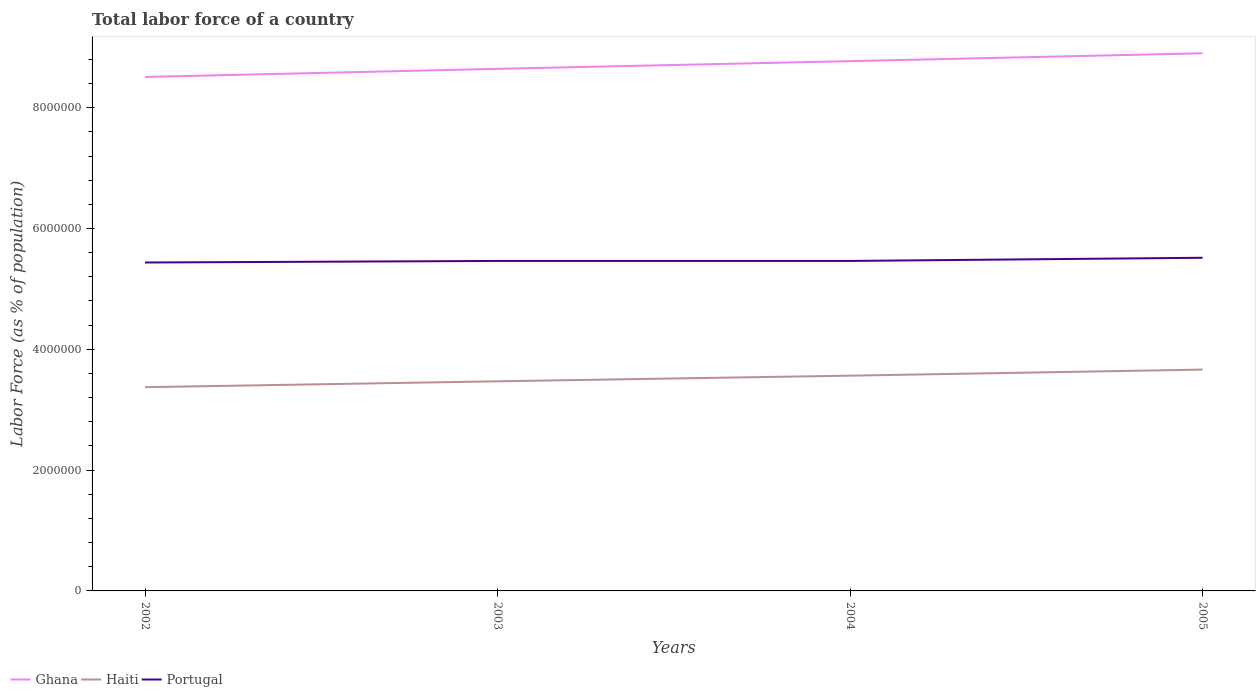Is the number of lines equal to the number of legend labels?
Give a very brief answer. Yes. Across all years, what is the maximum percentage of labor force in Haiti?
Provide a short and direct response. 3.37e+06. In which year was the percentage of labor force in Ghana maximum?
Ensure brevity in your answer.  2002. What is the total percentage of labor force in Ghana in the graph?
Your response must be concise. -2.57e+05. What is the difference between the highest and the second highest percentage of labor force in Haiti?
Offer a very short reply. 2.91e+05. How many years are there in the graph?
Provide a short and direct response. 4. What is the difference between two consecutive major ticks on the Y-axis?
Your answer should be compact. 2.00e+06. Where does the legend appear in the graph?
Give a very brief answer. Bottom left. How are the legend labels stacked?
Offer a very short reply. Horizontal. What is the title of the graph?
Ensure brevity in your answer.  Total labor force of a country. Does "Low income" appear as one of the legend labels in the graph?
Your response must be concise. No. What is the label or title of the X-axis?
Keep it short and to the point. Years. What is the label or title of the Y-axis?
Offer a very short reply. Labor Force (as % of population). What is the Labor Force (as % of population) in Ghana in 2002?
Your answer should be compact. 8.51e+06. What is the Labor Force (as % of population) in Haiti in 2002?
Your response must be concise. 3.37e+06. What is the Labor Force (as % of population) in Portugal in 2002?
Keep it short and to the point. 5.44e+06. What is the Labor Force (as % of population) of Ghana in 2003?
Your answer should be compact. 8.64e+06. What is the Labor Force (as % of population) in Haiti in 2003?
Keep it short and to the point. 3.47e+06. What is the Labor Force (as % of population) of Portugal in 2003?
Keep it short and to the point. 5.46e+06. What is the Labor Force (as % of population) of Ghana in 2004?
Make the answer very short. 8.77e+06. What is the Labor Force (as % of population) of Haiti in 2004?
Your answer should be compact. 3.56e+06. What is the Labor Force (as % of population) in Portugal in 2004?
Your answer should be compact. 5.46e+06. What is the Labor Force (as % of population) of Ghana in 2005?
Offer a terse response. 8.90e+06. What is the Labor Force (as % of population) in Haiti in 2005?
Offer a very short reply. 3.66e+06. What is the Labor Force (as % of population) of Portugal in 2005?
Offer a terse response. 5.52e+06. Across all years, what is the maximum Labor Force (as % of population) in Ghana?
Make the answer very short. 8.90e+06. Across all years, what is the maximum Labor Force (as % of population) of Haiti?
Give a very brief answer. 3.66e+06. Across all years, what is the maximum Labor Force (as % of population) in Portugal?
Keep it short and to the point. 5.52e+06. Across all years, what is the minimum Labor Force (as % of population) of Ghana?
Your answer should be compact. 8.51e+06. Across all years, what is the minimum Labor Force (as % of population) of Haiti?
Provide a succinct answer. 3.37e+06. Across all years, what is the minimum Labor Force (as % of population) of Portugal?
Offer a terse response. 5.44e+06. What is the total Labor Force (as % of population) in Ghana in the graph?
Your answer should be compact. 3.48e+07. What is the total Labor Force (as % of population) in Haiti in the graph?
Your answer should be compact. 1.41e+07. What is the total Labor Force (as % of population) of Portugal in the graph?
Offer a terse response. 2.19e+07. What is the difference between the Labor Force (as % of population) of Ghana in 2002 and that in 2003?
Keep it short and to the point. -1.35e+05. What is the difference between the Labor Force (as % of population) in Haiti in 2002 and that in 2003?
Provide a succinct answer. -9.76e+04. What is the difference between the Labor Force (as % of population) of Portugal in 2002 and that in 2003?
Keep it short and to the point. -2.58e+04. What is the difference between the Labor Force (as % of population) in Ghana in 2002 and that in 2004?
Offer a terse response. -2.62e+05. What is the difference between the Labor Force (as % of population) in Haiti in 2002 and that in 2004?
Make the answer very short. -1.91e+05. What is the difference between the Labor Force (as % of population) in Portugal in 2002 and that in 2004?
Give a very brief answer. -2.60e+04. What is the difference between the Labor Force (as % of population) of Ghana in 2002 and that in 2005?
Provide a short and direct response. -3.92e+05. What is the difference between the Labor Force (as % of population) of Haiti in 2002 and that in 2005?
Provide a short and direct response. -2.91e+05. What is the difference between the Labor Force (as % of population) of Portugal in 2002 and that in 2005?
Ensure brevity in your answer.  -7.84e+04. What is the difference between the Labor Force (as % of population) of Ghana in 2003 and that in 2004?
Offer a terse response. -1.27e+05. What is the difference between the Labor Force (as % of population) in Haiti in 2003 and that in 2004?
Make the answer very short. -9.34e+04. What is the difference between the Labor Force (as % of population) in Portugal in 2003 and that in 2004?
Give a very brief answer. -173. What is the difference between the Labor Force (as % of population) of Ghana in 2003 and that in 2005?
Offer a terse response. -2.57e+05. What is the difference between the Labor Force (as % of population) of Haiti in 2003 and that in 2005?
Offer a very short reply. -1.94e+05. What is the difference between the Labor Force (as % of population) of Portugal in 2003 and that in 2005?
Give a very brief answer. -5.25e+04. What is the difference between the Labor Force (as % of population) of Ghana in 2004 and that in 2005?
Offer a terse response. -1.31e+05. What is the difference between the Labor Force (as % of population) of Haiti in 2004 and that in 2005?
Offer a terse response. -1.00e+05. What is the difference between the Labor Force (as % of population) of Portugal in 2004 and that in 2005?
Offer a very short reply. -5.23e+04. What is the difference between the Labor Force (as % of population) in Ghana in 2002 and the Labor Force (as % of population) in Haiti in 2003?
Make the answer very short. 5.04e+06. What is the difference between the Labor Force (as % of population) in Ghana in 2002 and the Labor Force (as % of population) in Portugal in 2003?
Keep it short and to the point. 3.05e+06. What is the difference between the Labor Force (as % of population) in Haiti in 2002 and the Labor Force (as % of population) in Portugal in 2003?
Offer a very short reply. -2.09e+06. What is the difference between the Labor Force (as % of population) of Ghana in 2002 and the Labor Force (as % of population) of Haiti in 2004?
Provide a short and direct response. 4.95e+06. What is the difference between the Labor Force (as % of population) in Ghana in 2002 and the Labor Force (as % of population) in Portugal in 2004?
Offer a very short reply. 3.05e+06. What is the difference between the Labor Force (as % of population) of Haiti in 2002 and the Labor Force (as % of population) of Portugal in 2004?
Ensure brevity in your answer.  -2.09e+06. What is the difference between the Labor Force (as % of population) in Ghana in 2002 and the Labor Force (as % of population) in Haiti in 2005?
Make the answer very short. 4.84e+06. What is the difference between the Labor Force (as % of population) of Ghana in 2002 and the Labor Force (as % of population) of Portugal in 2005?
Give a very brief answer. 2.99e+06. What is the difference between the Labor Force (as % of population) of Haiti in 2002 and the Labor Force (as % of population) of Portugal in 2005?
Provide a succinct answer. -2.14e+06. What is the difference between the Labor Force (as % of population) of Ghana in 2003 and the Labor Force (as % of population) of Haiti in 2004?
Offer a terse response. 5.08e+06. What is the difference between the Labor Force (as % of population) in Ghana in 2003 and the Labor Force (as % of population) in Portugal in 2004?
Keep it short and to the point. 3.18e+06. What is the difference between the Labor Force (as % of population) of Haiti in 2003 and the Labor Force (as % of population) of Portugal in 2004?
Offer a terse response. -1.99e+06. What is the difference between the Labor Force (as % of population) in Ghana in 2003 and the Labor Force (as % of population) in Haiti in 2005?
Your answer should be compact. 4.98e+06. What is the difference between the Labor Force (as % of population) of Ghana in 2003 and the Labor Force (as % of population) of Portugal in 2005?
Offer a very short reply. 3.13e+06. What is the difference between the Labor Force (as % of population) of Haiti in 2003 and the Labor Force (as % of population) of Portugal in 2005?
Provide a succinct answer. -2.04e+06. What is the difference between the Labor Force (as % of population) of Ghana in 2004 and the Labor Force (as % of population) of Haiti in 2005?
Offer a very short reply. 5.11e+06. What is the difference between the Labor Force (as % of population) in Ghana in 2004 and the Labor Force (as % of population) in Portugal in 2005?
Your response must be concise. 3.26e+06. What is the difference between the Labor Force (as % of population) of Haiti in 2004 and the Labor Force (as % of population) of Portugal in 2005?
Make the answer very short. -1.95e+06. What is the average Labor Force (as % of population) of Ghana per year?
Your answer should be very brief. 8.71e+06. What is the average Labor Force (as % of population) of Haiti per year?
Ensure brevity in your answer.  3.52e+06. What is the average Labor Force (as % of population) of Portugal per year?
Give a very brief answer. 5.47e+06. In the year 2002, what is the difference between the Labor Force (as % of population) in Ghana and Labor Force (as % of population) in Haiti?
Your answer should be very brief. 5.14e+06. In the year 2002, what is the difference between the Labor Force (as % of population) of Ghana and Labor Force (as % of population) of Portugal?
Your answer should be very brief. 3.07e+06. In the year 2002, what is the difference between the Labor Force (as % of population) in Haiti and Labor Force (as % of population) in Portugal?
Provide a succinct answer. -2.06e+06. In the year 2003, what is the difference between the Labor Force (as % of population) of Ghana and Labor Force (as % of population) of Haiti?
Your response must be concise. 5.17e+06. In the year 2003, what is the difference between the Labor Force (as % of population) of Ghana and Labor Force (as % of population) of Portugal?
Offer a very short reply. 3.18e+06. In the year 2003, what is the difference between the Labor Force (as % of population) in Haiti and Labor Force (as % of population) in Portugal?
Offer a very short reply. -1.99e+06. In the year 2004, what is the difference between the Labor Force (as % of population) of Ghana and Labor Force (as % of population) of Haiti?
Offer a terse response. 5.21e+06. In the year 2004, what is the difference between the Labor Force (as % of population) of Ghana and Labor Force (as % of population) of Portugal?
Your response must be concise. 3.31e+06. In the year 2004, what is the difference between the Labor Force (as % of population) of Haiti and Labor Force (as % of population) of Portugal?
Offer a terse response. -1.90e+06. In the year 2005, what is the difference between the Labor Force (as % of population) in Ghana and Labor Force (as % of population) in Haiti?
Provide a short and direct response. 5.24e+06. In the year 2005, what is the difference between the Labor Force (as % of population) of Ghana and Labor Force (as % of population) of Portugal?
Offer a very short reply. 3.39e+06. In the year 2005, what is the difference between the Labor Force (as % of population) of Haiti and Labor Force (as % of population) of Portugal?
Your answer should be compact. -1.85e+06. What is the ratio of the Labor Force (as % of population) in Ghana in 2002 to that in 2003?
Ensure brevity in your answer.  0.98. What is the ratio of the Labor Force (as % of population) in Haiti in 2002 to that in 2003?
Provide a succinct answer. 0.97. What is the ratio of the Labor Force (as % of population) in Ghana in 2002 to that in 2004?
Provide a succinct answer. 0.97. What is the ratio of the Labor Force (as % of population) in Haiti in 2002 to that in 2004?
Your response must be concise. 0.95. What is the ratio of the Labor Force (as % of population) of Ghana in 2002 to that in 2005?
Provide a short and direct response. 0.96. What is the ratio of the Labor Force (as % of population) in Haiti in 2002 to that in 2005?
Your answer should be very brief. 0.92. What is the ratio of the Labor Force (as % of population) of Portugal in 2002 to that in 2005?
Provide a short and direct response. 0.99. What is the ratio of the Labor Force (as % of population) in Ghana in 2003 to that in 2004?
Keep it short and to the point. 0.99. What is the ratio of the Labor Force (as % of population) of Haiti in 2003 to that in 2004?
Make the answer very short. 0.97. What is the ratio of the Labor Force (as % of population) of Portugal in 2003 to that in 2004?
Provide a short and direct response. 1. What is the ratio of the Labor Force (as % of population) in Ghana in 2003 to that in 2005?
Provide a short and direct response. 0.97. What is the ratio of the Labor Force (as % of population) of Haiti in 2003 to that in 2005?
Offer a terse response. 0.95. What is the ratio of the Labor Force (as % of population) in Portugal in 2003 to that in 2005?
Provide a short and direct response. 0.99. What is the ratio of the Labor Force (as % of population) in Ghana in 2004 to that in 2005?
Give a very brief answer. 0.99. What is the ratio of the Labor Force (as % of population) of Haiti in 2004 to that in 2005?
Provide a short and direct response. 0.97. What is the difference between the highest and the second highest Labor Force (as % of population) in Ghana?
Your answer should be compact. 1.31e+05. What is the difference between the highest and the second highest Labor Force (as % of population) in Haiti?
Make the answer very short. 1.00e+05. What is the difference between the highest and the second highest Labor Force (as % of population) in Portugal?
Make the answer very short. 5.23e+04. What is the difference between the highest and the lowest Labor Force (as % of population) of Ghana?
Offer a very short reply. 3.92e+05. What is the difference between the highest and the lowest Labor Force (as % of population) in Haiti?
Offer a terse response. 2.91e+05. What is the difference between the highest and the lowest Labor Force (as % of population) in Portugal?
Make the answer very short. 7.84e+04. 